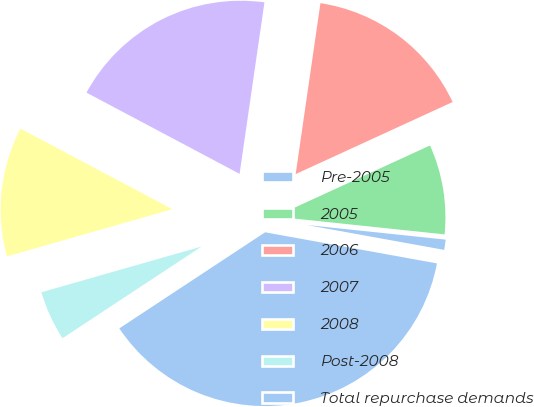Convert chart. <chart><loc_0><loc_0><loc_500><loc_500><pie_chart><fcel>Pre-2005<fcel>2005<fcel>2006<fcel>2007<fcel>2008<fcel>Post-2008<fcel>Total repurchase demands<nl><fcel>1.18%<fcel>8.52%<fcel>15.86%<fcel>19.53%<fcel>12.19%<fcel>4.85%<fcel>37.88%<nl></chart> 